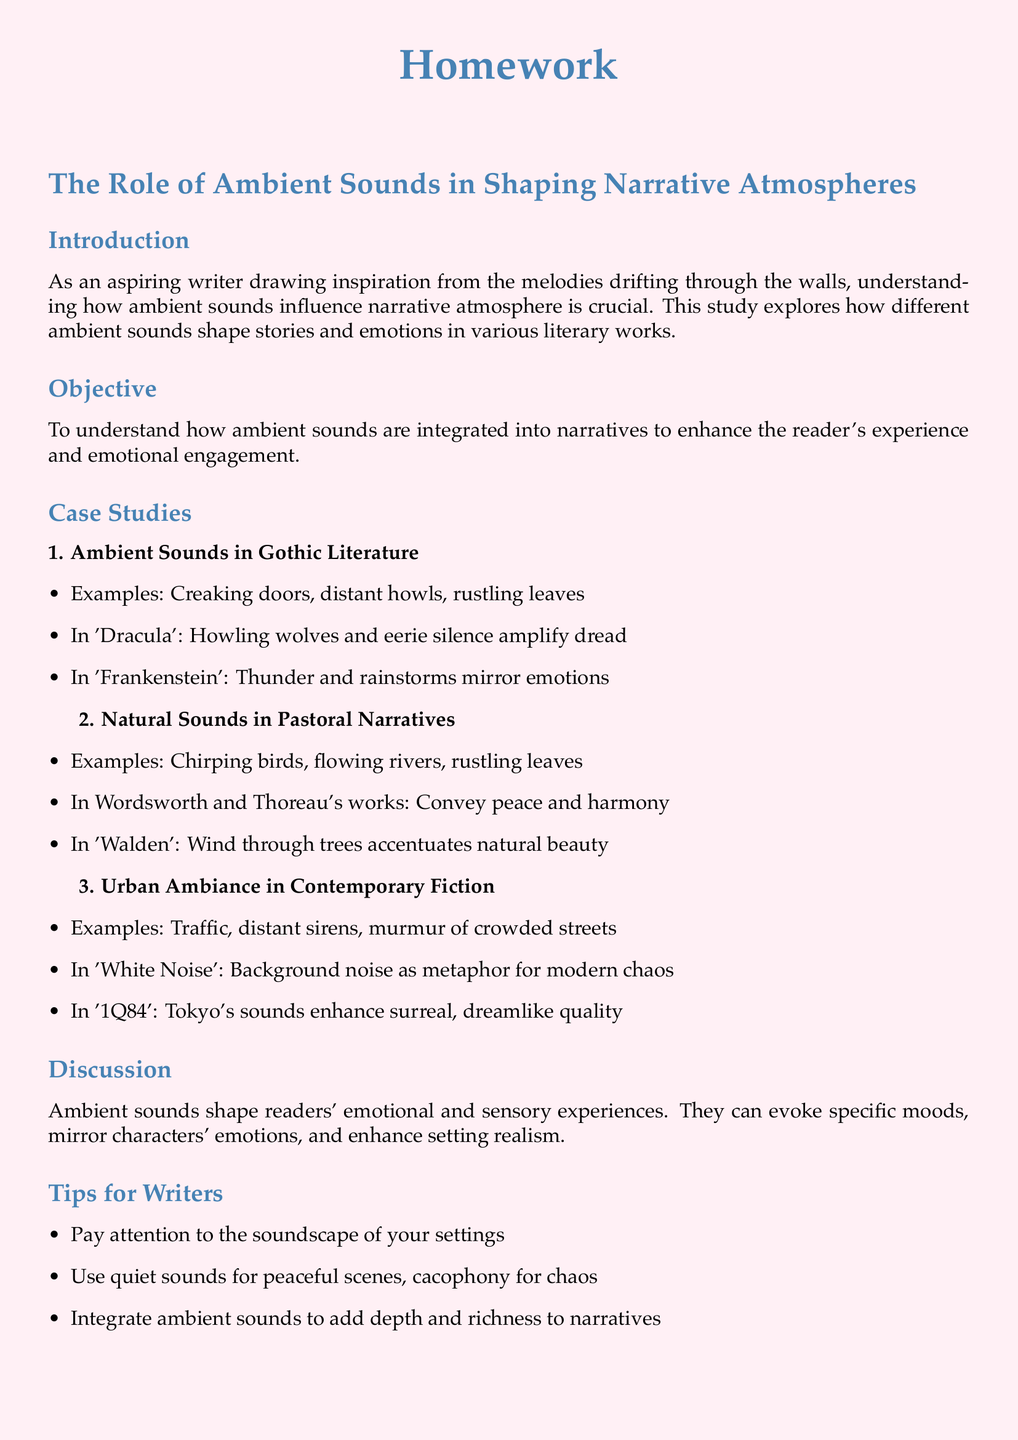What is the primary focus of the study? The study primarily focuses on how ambient sounds influence narrative atmosphere in literary works.
Answer: ambient sounds Name one example of ambient sounds found in Gothic literature. The document lists creaking doors as an example of ambient sounds in Gothic literature.
Answer: creaking doors What emotions do thunder and rainstorms mirror in 'Frankenstein'? The document states that thunder and rainstorms mirror emotions in 'Frankenstein'.
Answer: emotions Which author is associated with the work 'Walden'? The document mentions Thoreau as the author associated with the work 'Walden'.
Answer: Thoreau What type of sounds convey peace and harmony in pastoral narratives? The document indicates that chirping birds convey peace and harmony in pastoral narratives.
Answer: chirping birds What is a literary work mentioned that uses background noise as a metaphor for modern chaos? 'White Noise' is noted in the document for using background noise as a metaphor for modern chaos.
Answer: White Noise What are two types of ambient sounds suggested for different scenes? The document suggests quiet sounds for peaceful scenes and cacophony for chaos.
Answer: quiet sounds and cacophony What genre does '1Q84' belong to? The document implies that '1Q84' falls under contemporary fiction.
Answer: contemporary fiction Who is the intended audience of this homework document? The intended audience is aspiring writers who draw inspiration from ambient sounds.
Answer: aspiring writers 